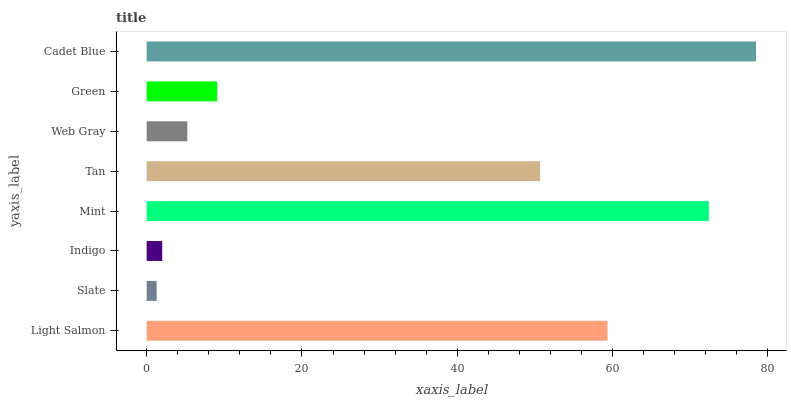Is Slate the minimum?
Answer yes or no. Yes. Is Cadet Blue the maximum?
Answer yes or no. Yes. Is Indigo the minimum?
Answer yes or no. No. Is Indigo the maximum?
Answer yes or no. No. Is Indigo greater than Slate?
Answer yes or no. Yes. Is Slate less than Indigo?
Answer yes or no. Yes. Is Slate greater than Indigo?
Answer yes or no. No. Is Indigo less than Slate?
Answer yes or no. No. Is Tan the high median?
Answer yes or no. Yes. Is Green the low median?
Answer yes or no. Yes. Is Mint the high median?
Answer yes or no. No. Is Slate the low median?
Answer yes or no. No. 